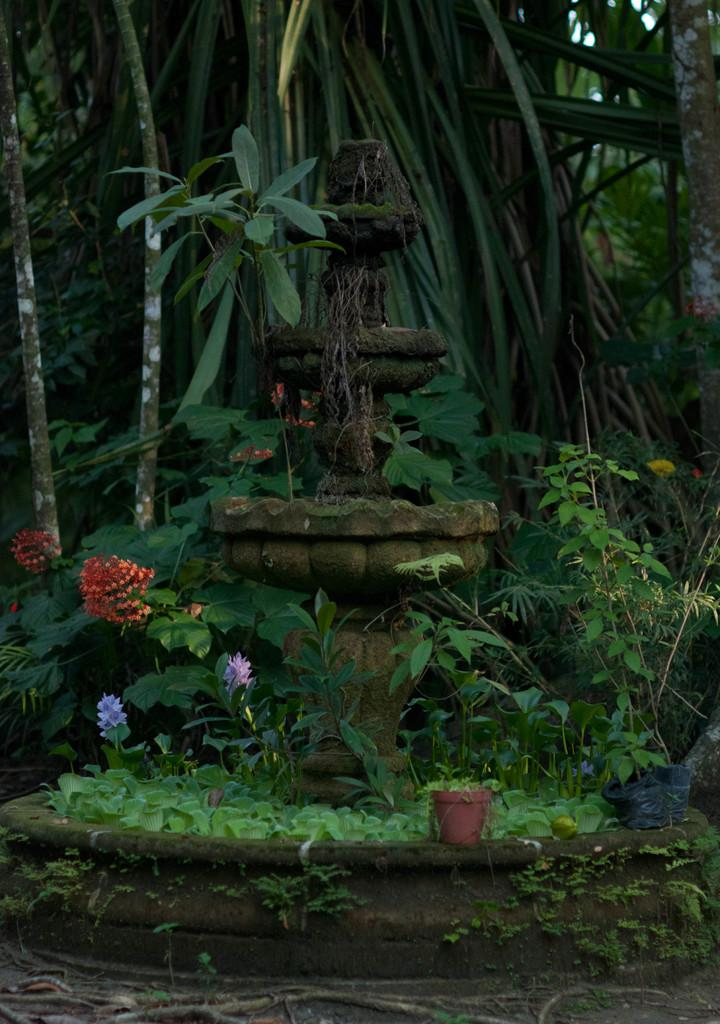What is the main feature in the image? There is a fountain in the image. What other elements can be seen in the image? There are plants and flowers in the image. What can be seen in the background of the image? There are trees in the background of the image. What type of locket is hanging from the fountain in the image? There is no locket present in the image; it features a fountain, plants, flowers, and trees. 